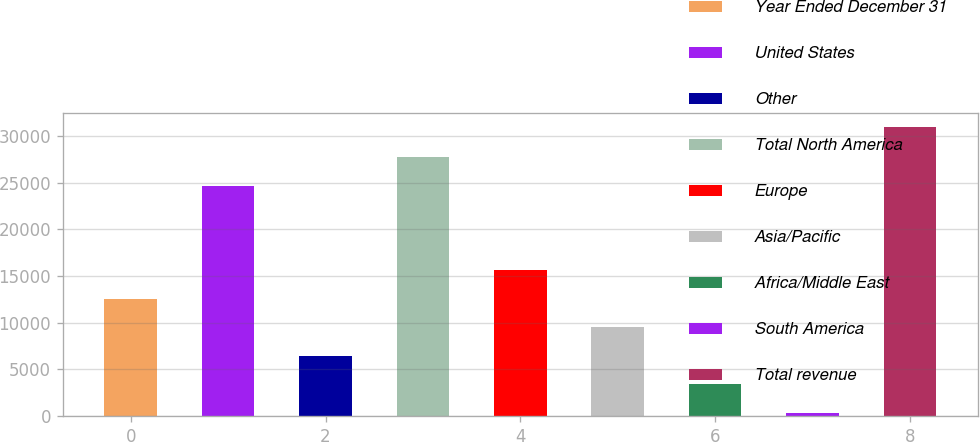Convert chart to OTSL. <chart><loc_0><loc_0><loc_500><loc_500><bar_chart><fcel>Year Ended December 31<fcel>United States<fcel>Other<fcel>Total North America<fcel>Europe<fcel>Asia/Pacific<fcel>Africa/Middle East<fcel>South America<fcel>Total revenue<nl><fcel>12568.8<fcel>24646<fcel>6448.4<fcel>27706.2<fcel>15629<fcel>9508.6<fcel>3388.2<fcel>328<fcel>30930<nl></chart> 